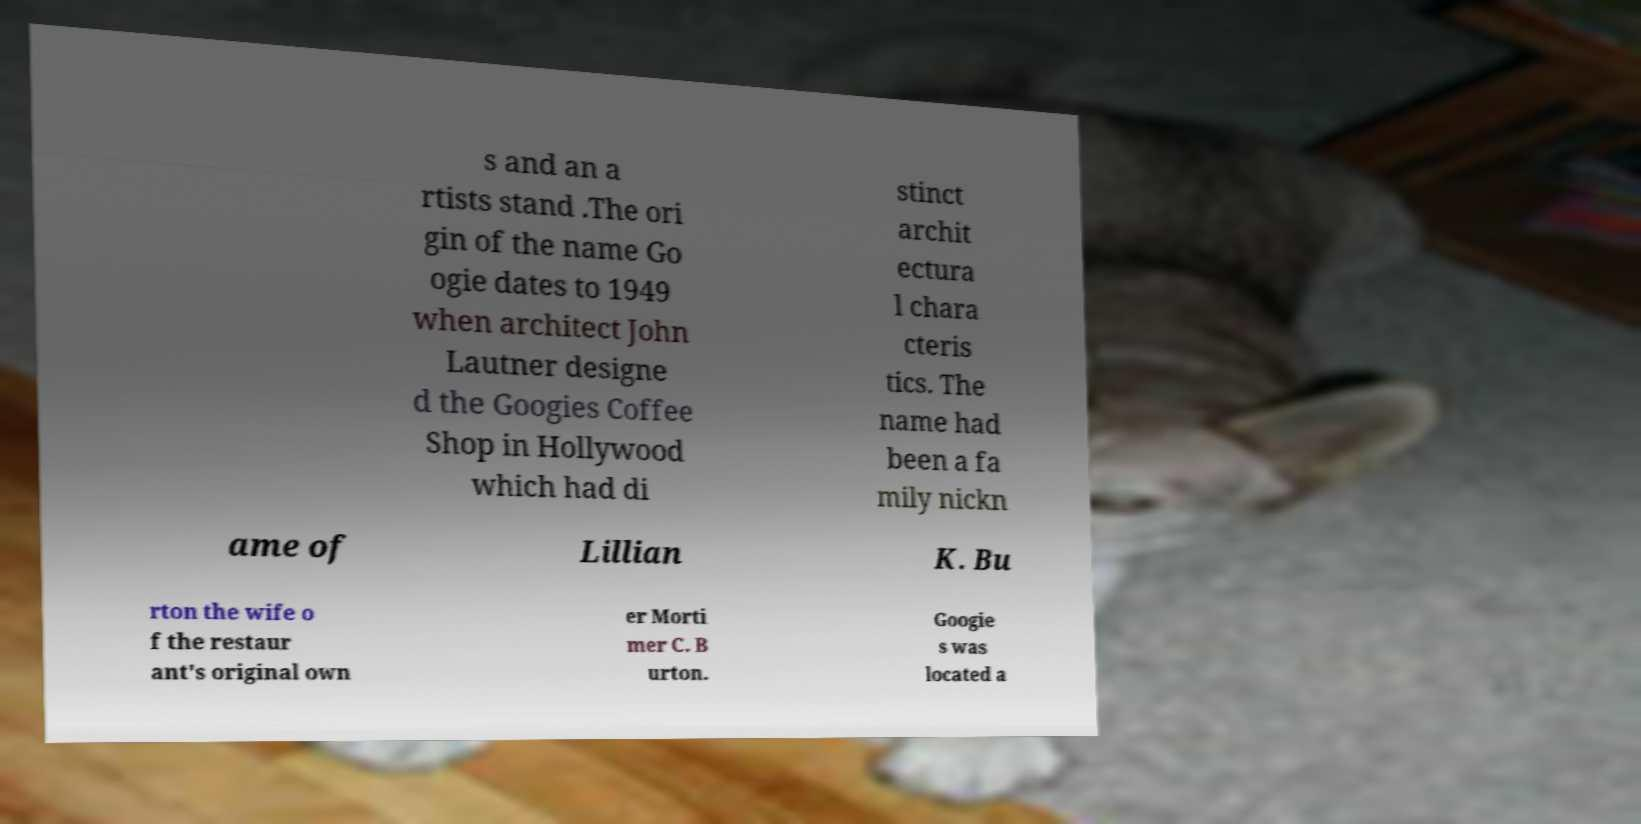For documentation purposes, I need the text within this image transcribed. Could you provide that? s and an a rtists stand .The ori gin of the name Go ogie dates to 1949 when architect John Lautner designe d the Googies Coffee Shop in Hollywood which had di stinct archit ectura l chara cteris tics. The name had been a fa mily nickn ame of Lillian K. Bu rton the wife o f the restaur ant's original own er Morti mer C. B urton. Googie s was located a 